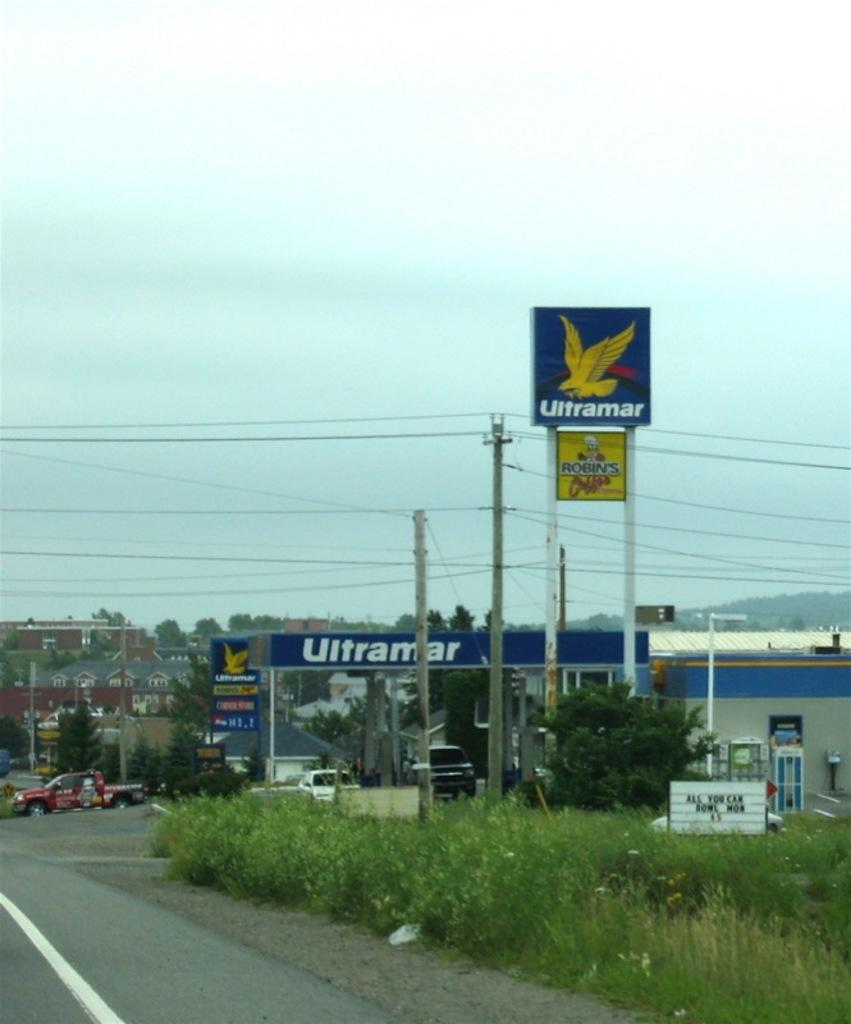<image>
Offer a succinct explanation of the picture presented. a petrol station called Ultramar has a blue sign with a yellow bird on it 